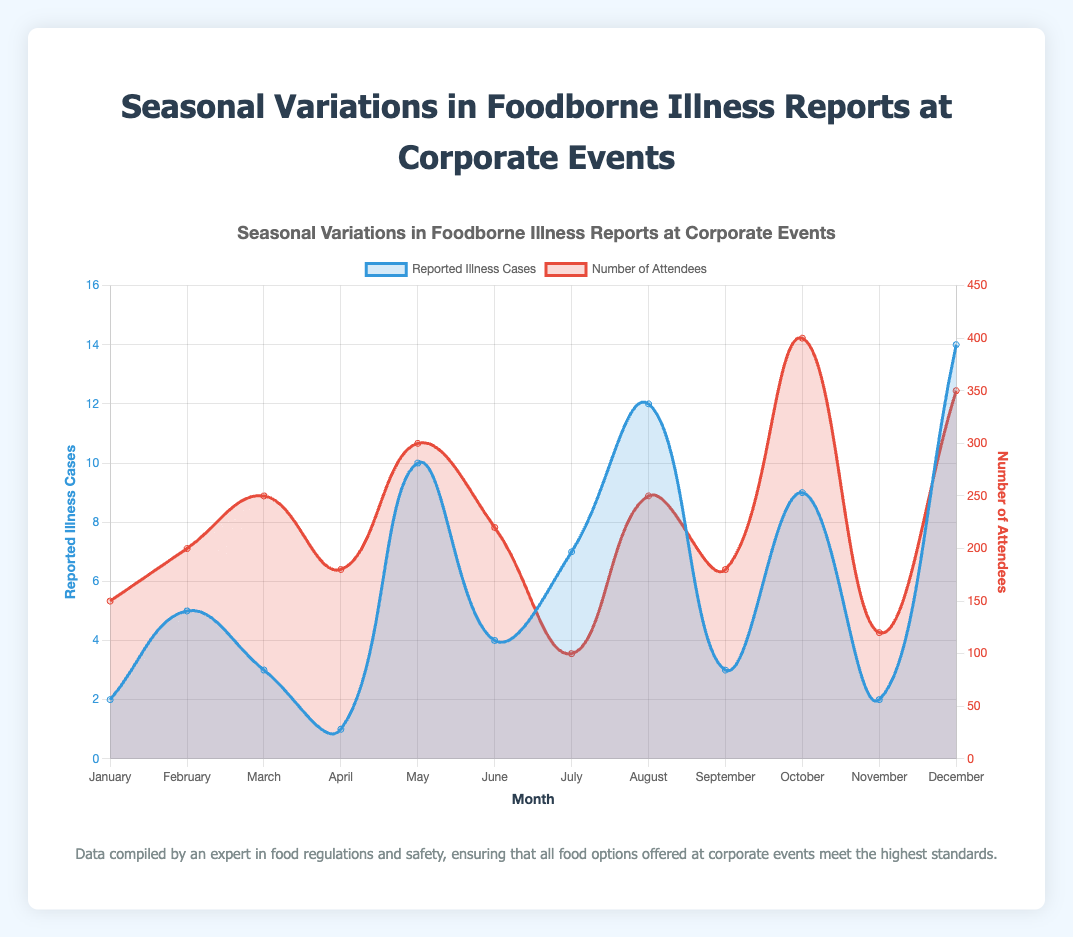What's the highest number of reported illness cases in a single month? By analyzing the curve labeled "Reported Illness Cases," we see that the highest peak occurs in December with 14 reported illness cases.
Answer: 14 In which month was the number of attendees the highest, and how many attendees were there? The curve labeled "Number of Attendees" shows the highest peak in October with 400 attendees.
Answer: October, 400 Which month had the highest difference between the number of attendees and reported illness cases? Comparing the two curves, December had 350 attendees and 14 reported illness cases, yielding a difference of 336. Other months have smaller differences.
Answer: December How many months had more than 5 reported illness cases? Looking at the "Reported Illness Cases" curve, the months with more than 5 cases are February, July, August, October, and December. That's a total of 5 months.
Answer: 5 What is the average number of reported illness cases per month? Summing up all the reported illness cases (2 + 5 + 3 + 1 + 10 + 4 + 7 + 12 + 3 + 9 + 2 + 14 = 72) and dividing by the 12 months gives the average: 72/12 = 6.
Answer: 6 Which month had the lowest reported illness cases, and how many cases were reported? The "Reported Illness Cases" curve shows the lowest point in April with 1 reported illness case.
Answer: April, 1 What is the range of reported illness cases across all months? The minimum reported illness cases is 1 (April), and the maximum is 14 (December). Thus, the range is 14 - 1 = 13.
Answer: 13 Which month(s) had both Norovirus and Salmonella as common pathogens? From the tooltip data, months January and May include both Norovirus and Salmonella as common pathogens.
Answer: January, May In which month and at which event was Staphylococcus a common pathogen? The tooltip data shows Staphylococcus as a common pathogen in March during the "Spring Product Launch" and in December during the "Year-End Celebration."
Answer: March, December What is the total number of attendees for events where Norovirus was a common pathogen? The months with Norovirus as a common pathogen are January, February, May, June, July, October, and December. Summing the number of attendees for these months (150 + 200 + 300 + 220 + 100 + 400 + 350 = 1720) gives the total.
Answer: 1720 